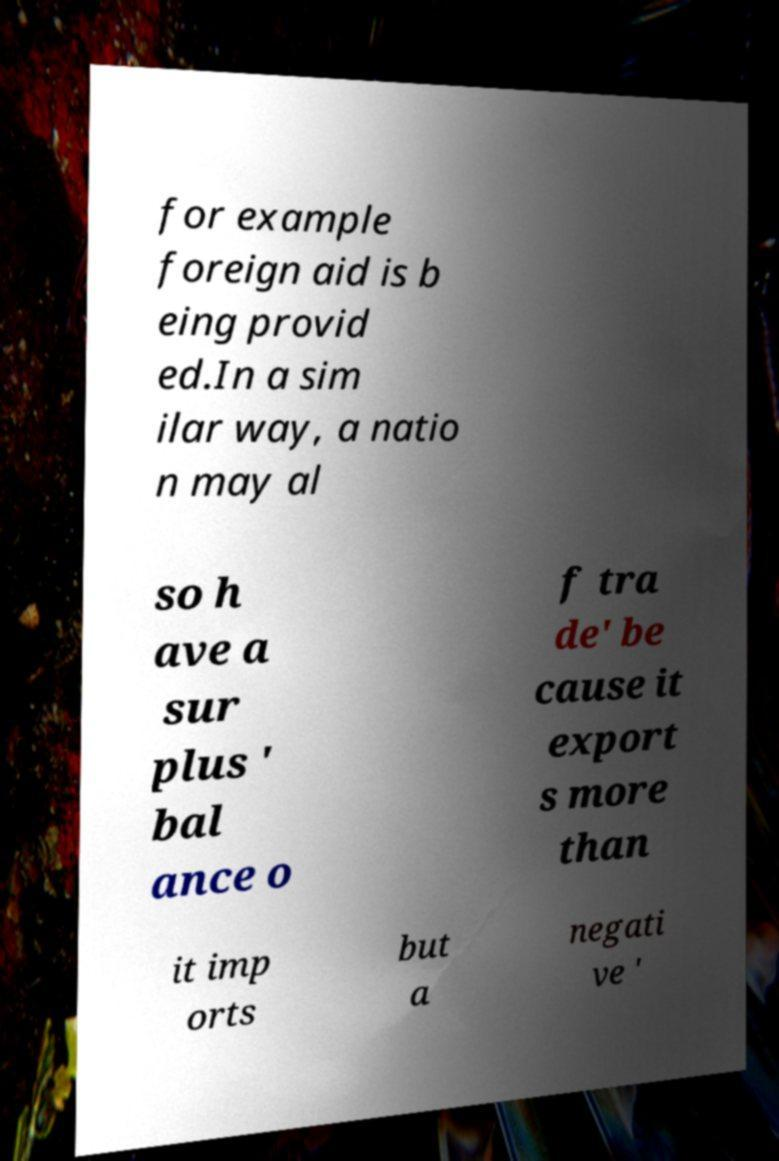Could you extract and type out the text from this image? for example foreign aid is b eing provid ed.In a sim ilar way, a natio n may al so h ave a sur plus ' bal ance o f tra de' be cause it export s more than it imp orts but a negati ve ' 